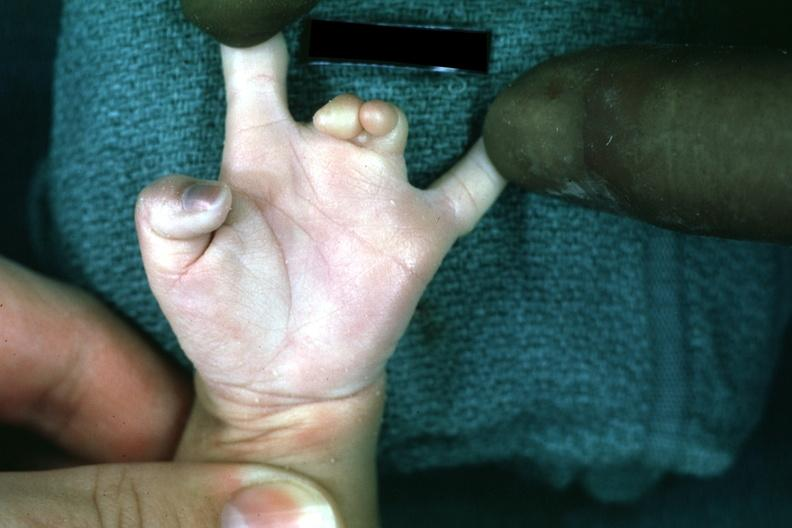s infant body present?
Answer the question using a single word or phrase. No 